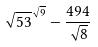Convert formula to latex. <formula><loc_0><loc_0><loc_500><loc_500>\sqrt { 5 3 } ^ { \sqrt { 9 } } - \frac { 4 9 4 } { \sqrt { 8 } }</formula> 